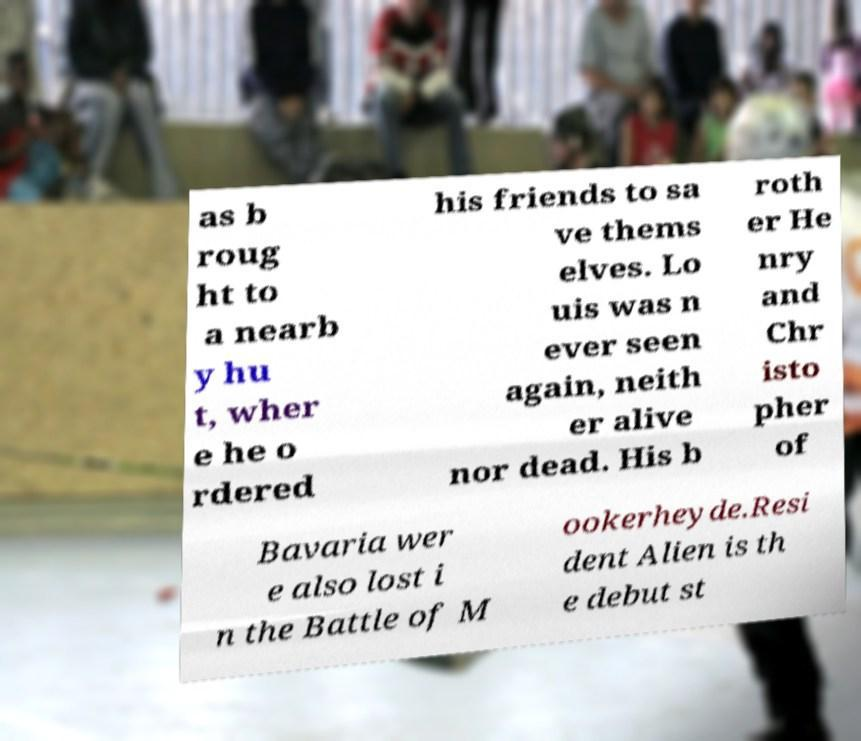For documentation purposes, I need the text within this image transcribed. Could you provide that? as b roug ht to a nearb y hu t, wher e he o rdered his friends to sa ve thems elves. Lo uis was n ever seen again, neith er alive nor dead. His b roth er He nry and Chr isto pher of Bavaria wer e also lost i n the Battle of M ookerheyde.Resi dent Alien is th e debut st 